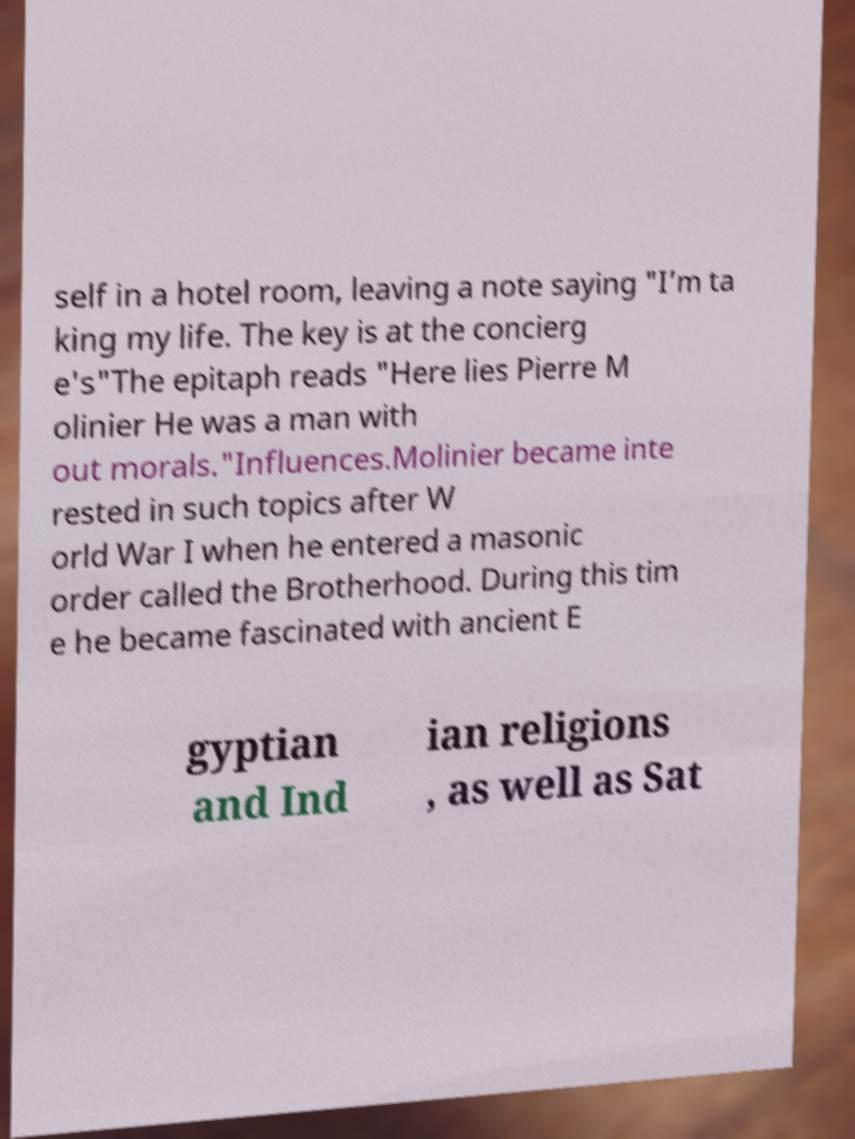I need the written content from this picture converted into text. Can you do that? self in a hotel room, leaving a note saying "I’m ta king my life. The key is at the concierg e's"The epitaph reads "Here lies Pierre M olinier He was a man with out morals."Influences.Molinier became inte rested in such topics after W orld War I when he entered a masonic order called the Brotherhood. During this tim e he became fascinated with ancient E gyptian and Ind ian religions , as well as Sat 